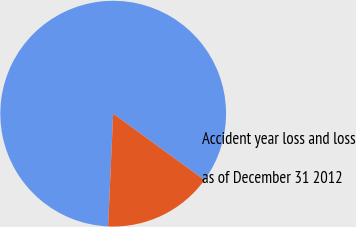Convert chart to OTSL. <chart><loc_0><loc_0><loc_500><loc_500><pie_chart><fcel>Accident year loss and loss<fcel>as of December 31 2012<nl><fcel>84.29%<fcel>15.71%<nl></chart> 